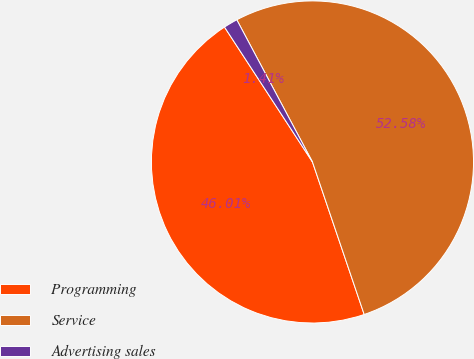Convert chart to OTSL. <chart><loc_0><loc_0><loc_500><loc_500><pie_chart><fcel>Programming<fcel>Service<fcel>Advertising sales<nl><fcel>46.01%<fcel>52.58%<fcel>1.41%<nl></chart> 